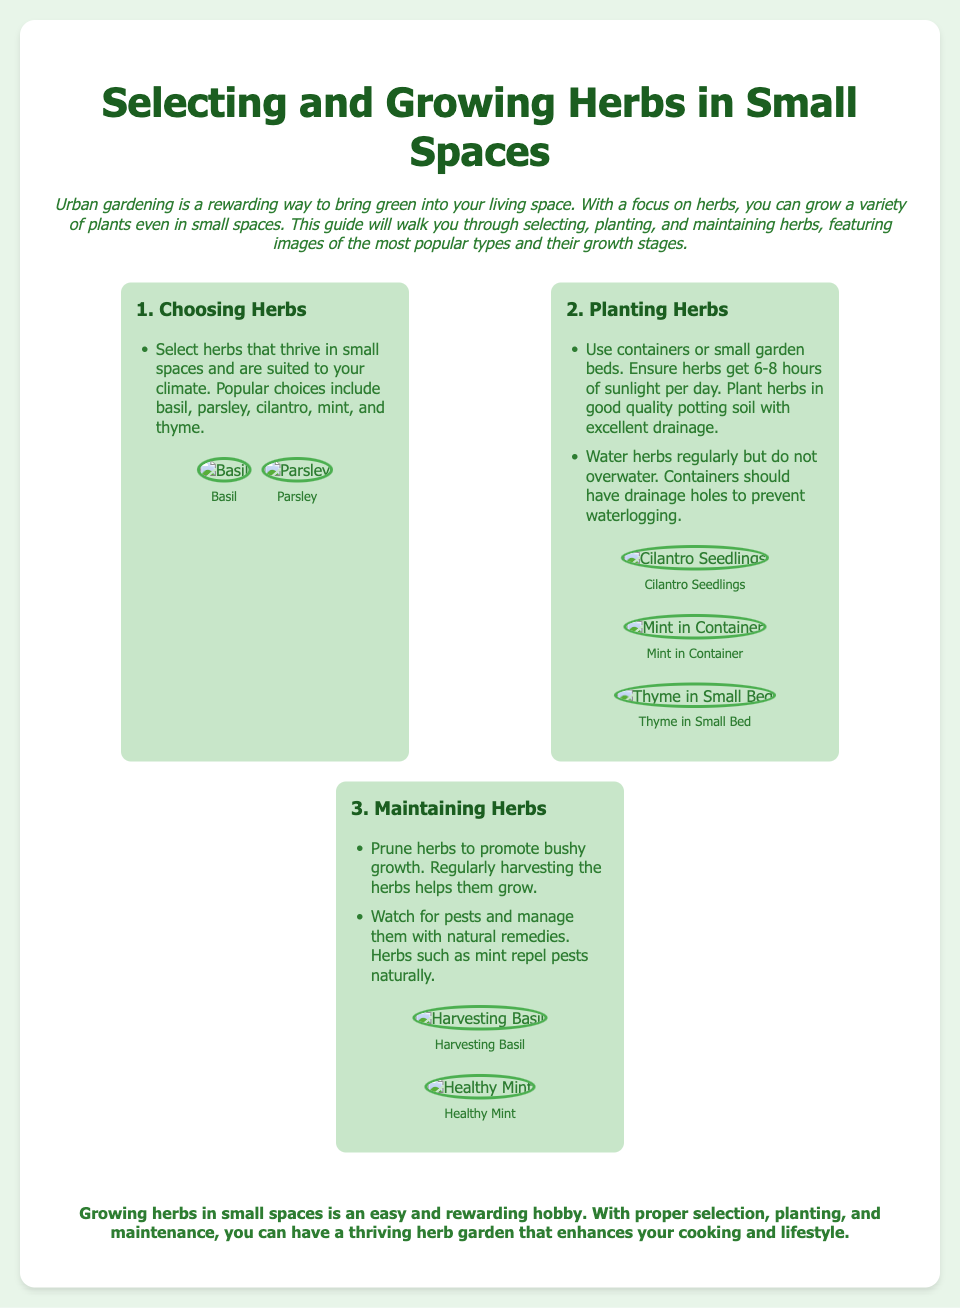What herbs are suggested for small spaces? The document lists popular herbs such as basil, parsley, cilantro, mint, and thyme for small spaces.
Answer: basil, parsley, cilantro, mint, thyme How many hours of sunlight do herbs need? The document states that herbs require 6-8 hours of sunlight per day for optimal growth.
Answer: 6-8 hours What type of soil should be used for planting herbs? The guide recommends using good quality potting soil with excellent drainage for planting herbs.
Answer: good quality potting soil What should you do to promote bushy growth in herbs? The document suggests pruning herbs and regularly harvesting them to encourage bushy growth.
Answer: prune and harvest Which herb is shown being harvested in the photos? The document features a photo of harvesting basil, identifying it specifically in the images.
Answer: basil What natural ways can be used to combat pests on herbs? The document mentions managing pests with natural remedies, highlighting that mint repels pests naturally.
Answer: mint What is the main focus of this guide? The focus of the guide is on selecting, planting, and maintaining herbs in small spaces.
Answer: herbs in small spaces How is the information about herbs presented visually? The document includes photos of different herb types and their growth stages to illustrate the information.
Answer: photos of herbs and growth stages Which herb is depicted in a container in the photos? A photo in the document specifically shows mint growing in a container.
Answer: mint 